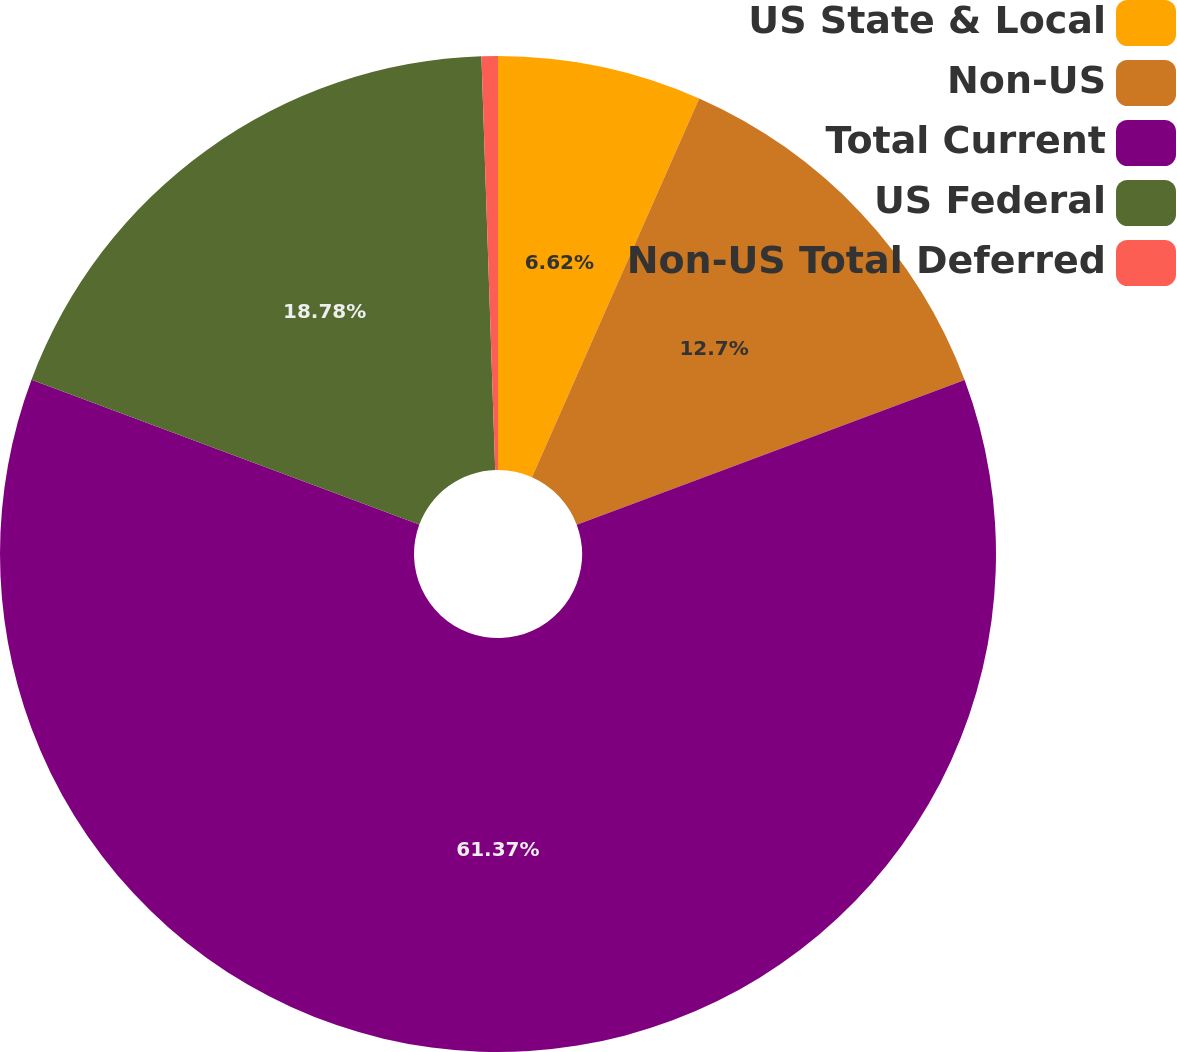Convert chart to OTSL. <chart><loc_0><loc_0><loc_500><loc_500><pie_chart><fcel>US State & Local<fcel>Non-US<fcel>Total Current<fcel>US Federal<fcel>Non-US Total Deferred<nl><fcel>6.62%<fcel>12.7%<fcel>61.37%<fcel>18.78%<fcel>0.53%<nl></chart> 